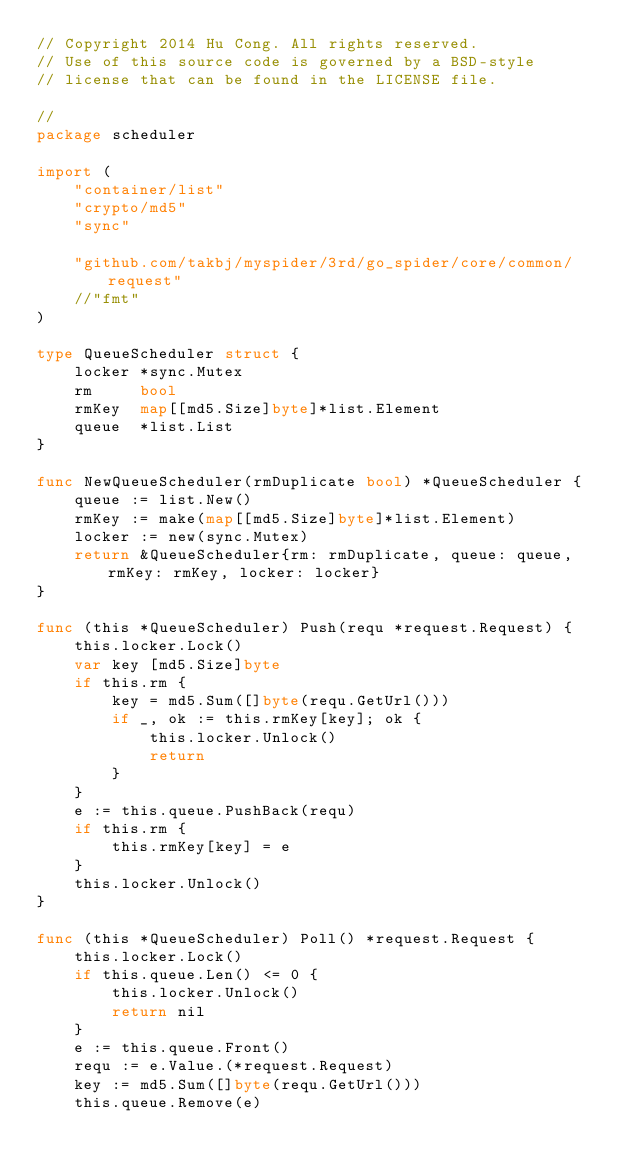<code> <loc_0><loc_0><loc_500><loc_500><_Go_>// Copyright 2014 Hu Cong. All rights reserved.
// Use of this source code is governed by a BSD-style
// license that can be found in the LICENSE file.

//
package scheduler

import (
	"container/list"
	"crypto/md5"
	"sync"

	"github.com/takbj/myspider/3rd/go_spider/core/common/request"
	//"fmt"
)

type QueueScheduler struct {
	locker *sync.Mutex
	rm     bool
	rmKey  map[[md5.Size]byte]*list.Element
	queue  *list.List
}

func NewQueueScheduler(rmDuplicate bool) *QueueScheduler {
	queue := list.New()
	rmKey := make(map[[md5.Size]byte]*list.Element)
	locker := new(sync.Mutex)
	return &QueueScheduler{rm: rmDuplicate, queue: queue, rmKey: rmKey, locker: locker}
}

func (this *QueueScheduler) Push(requ *request.Request) {
	this.locker.Lock()
	var key [md5.Size]byte
	if this.rm {
		key = md5.Sum([]byte(requ.GetUrl()))
		if _, ok := this.rmKey[key]; ok {
			this.locker.Unlock()
			return
		}
	}
	e := this.queue.PushBack(requ)
	if this.rm {
		this.rmKey[key] = e
	}
	this.locker.Unlock()
}

func (this *QueueScheduler) Poll() *request.Request {
	this.locker.Lock()
	if this.queue.Len() <= 0 {
		this.locker.Unlock()
		return nil
	}
	e := this.queue.Front()
	requ := e.Value.(*request.Request)
	key := md5.Sum([]byte(requ.GetUrl()))
	this.queue.Remove(e)</code> 